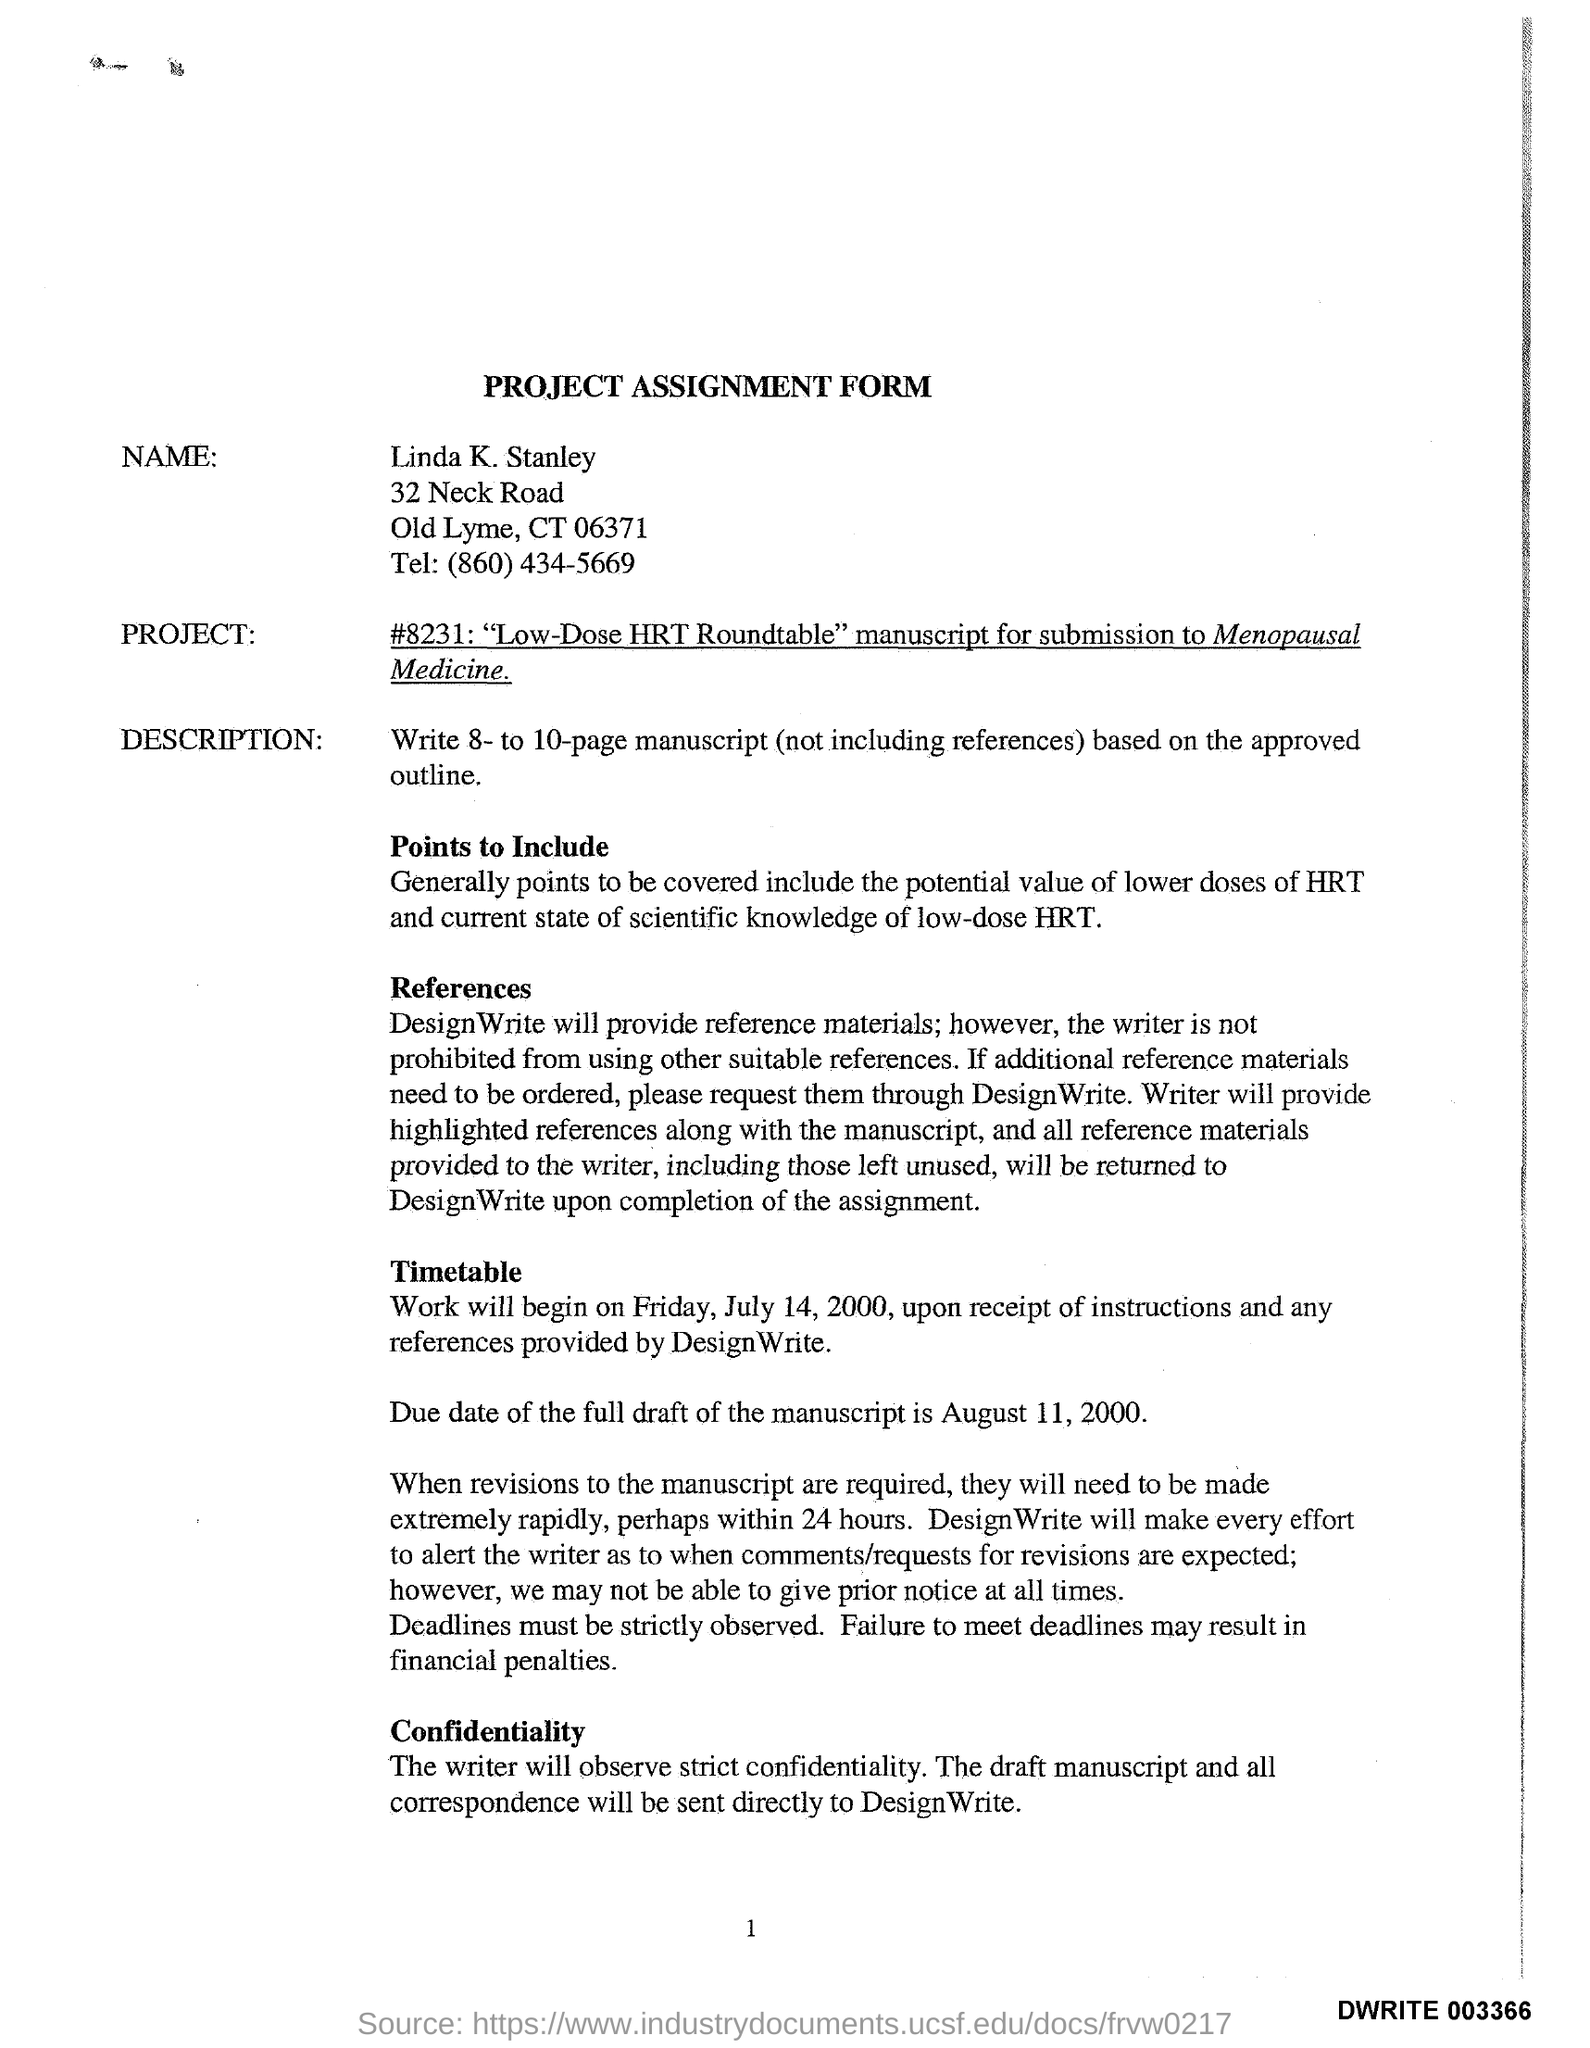Draw attention to some important aspects in this diagram. The name mentioned in the form is Linda K. Stanley. 